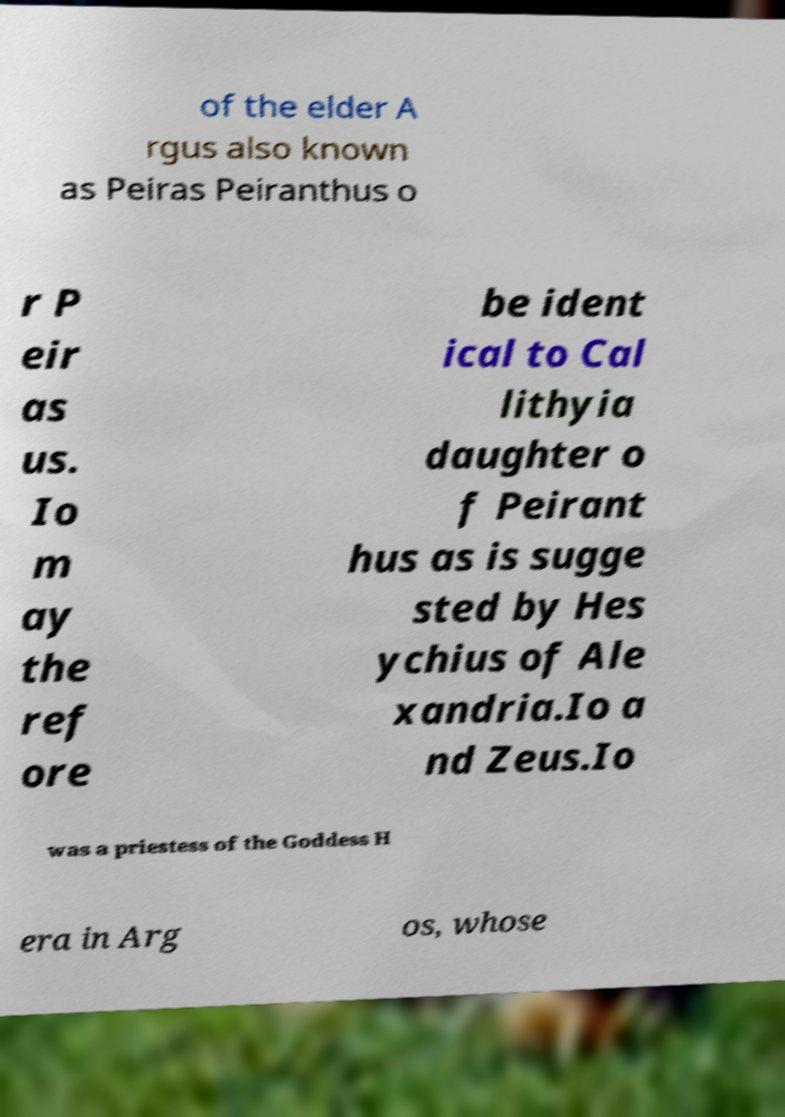What messages or text are displayed in this image? I need them in a readable, typed format. The text in the image appears to relate to ancient mythology and reads: 'of the elder Argus also known as Peiras Peiranthus or Peirasus. Io may therefore be identical to Callithyia, daughter of Peiranthus as is suggested by Hesychius of Alexandria. Io and Zeus. Io was a priestess of the Goddess Hera in Argos, whose'. The text mentions characters and mythological contexts, possibly from a mythological or historical study document. 